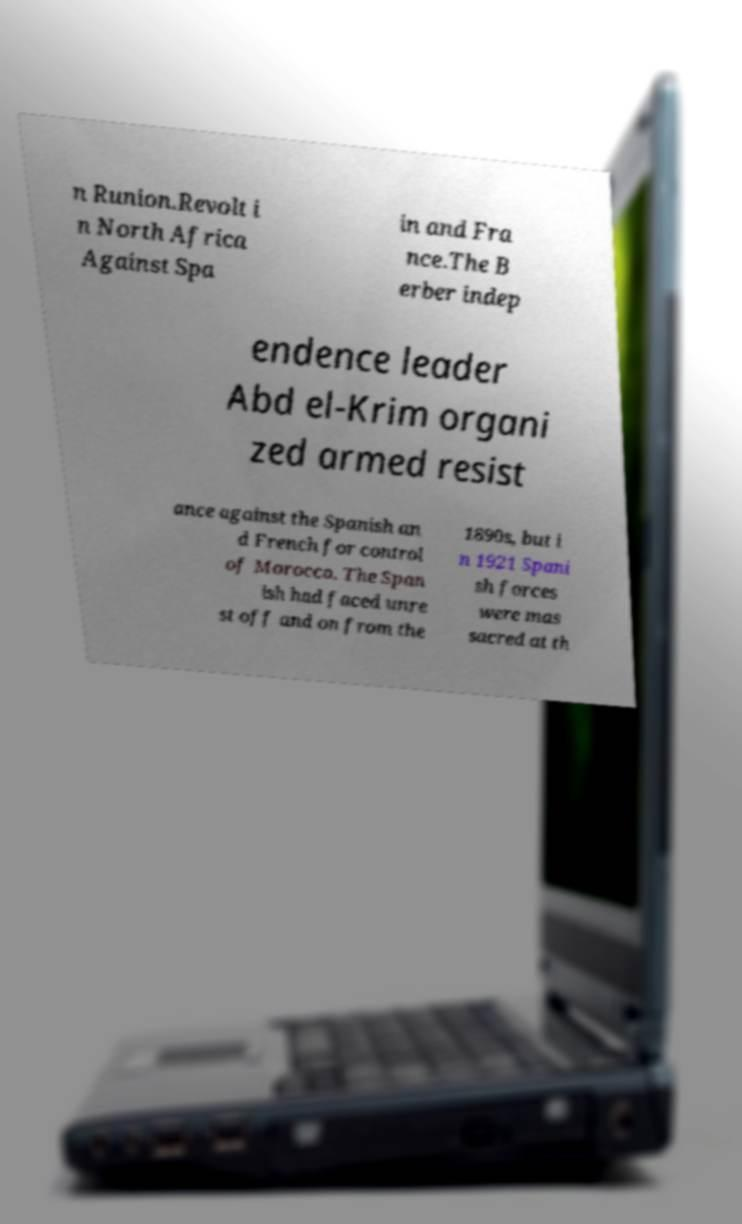Can you read and provide the text displayed in the image?This photo seems to have some interesting text. Can you extract and type it out for me? n Runion.Revolt i n North Africa Against Spa in and Fra nce.The B erber indep endence leader Abd el-Krim organi zed armed resist ance against the Spanish an d French for control of Morocco. The Span ish had faced unre st off and on from the 1890s, but i n 1921 Spani sh forces were mas sacred at th 